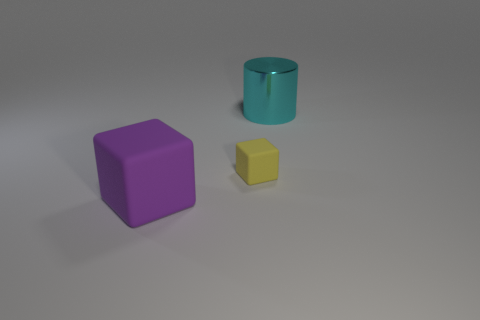Add 2 small brown rubber objects. How many objects exist? 5 Subtract all brown spheres. How many yellow cubes are left? 1 Subtract 1 cylinders. How many cylinders are left? 0 Subtract all cyan metal things. Subtract all red shiny spheres. How many objects are left? 2 Add 3 purple rubber things. How many purple rubber things are left? 4 Add 1 tiny yellow rubber things. How many tiny yellow rubber things exist? 2 Subtract 1 cyan cylinders. How many objects are left? 2 Subtract all blocks. How many objects are left? 1 Subtract all green cylinders. Subtract all cyan balls. How many cylinders are left? 1 